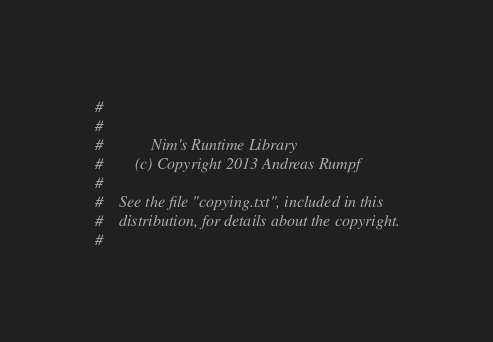<code> <loc_0><loc_0><loc_500><loc_500><_Nim_>#
#
#            Nim's Runtime Library
#        (c) Copyright 2013 Andreas Rumpf
#
#    See the file "copying.txt", included in this
#    distribution, for details about the copyright.
#

</code> 